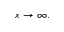Convert formula to latex. <formula><loc_0><loc_0><loc_500><loc_500>x \rightarrow \infty .</formula> 